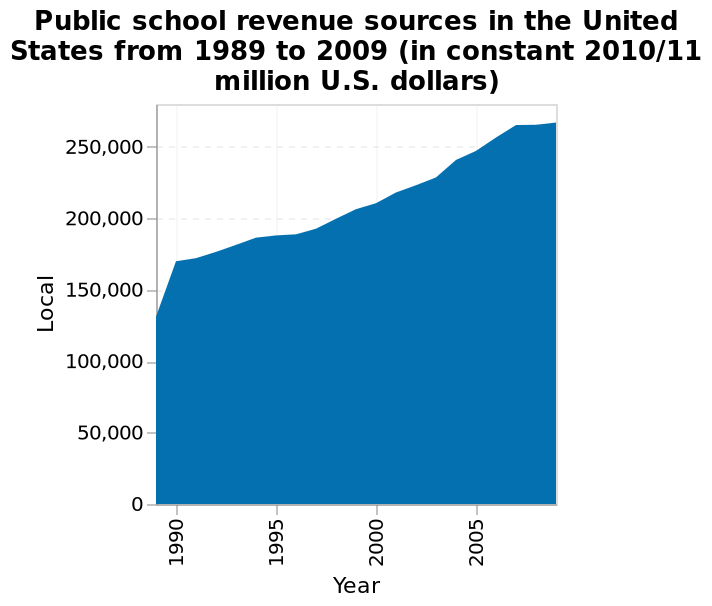<image>
What year had the lowest level of spending on public school revenue resources in the United States? 1990. What does the x-axis represent in the area graph?  The x-axis represents "Year" in the area graph. Offer a thorough analysis of the image. 1990 shows the lowest level of spending on public school revenue resources in the United States. Every year the spend increases. 